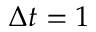<formula> <loc_0><loc_0><loc_500><loc_500>\Delta t = 1</formula> 